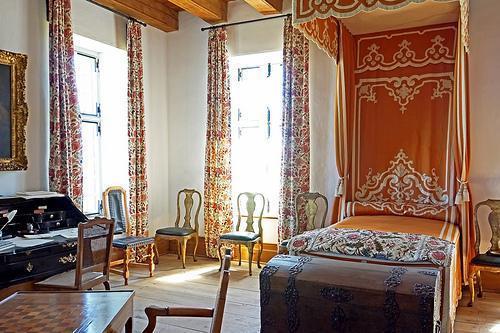How many beds are there?
Give a very brief answer. 1. 